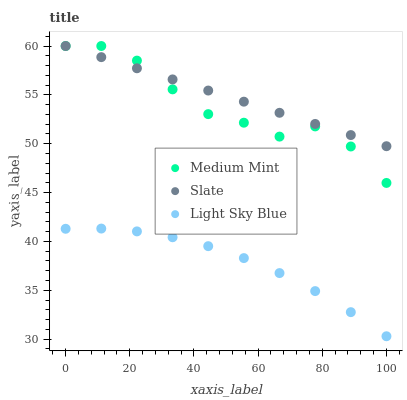Does Light Sky Blue have the minimum area under the curve?
Answer yes or no. Yes. Does Slate have the maximum area under the curve?
Answer yes or no. Yes. Does Slate have the minimum area under the curve?
Answer yes or no. No. Does Light Sky Blue have the maximum area under the curve?
Answer yes or no. No. Is Slate the smoothest?
Answer yes or no. Yes. Is Medium Mint the roughest?
Answer yes or no. Yes. Is Light Sky Blue the smoothest?
Answer yes or no. No. Is Light Sky Blue the roughest?
Answer yes or no. No. Does Light Sky Blue have the lowest value?
Answer yes or no. Yes. Does Slate have the lowest value?
Answer yes or no. No. Does Slate have the highest value?
Answer yes or no. Yes. Does Light Sky Blue have the highest value?
Answer yes or no. No. Is Light Sky Blue less than Medium Mint?
Answer yes or no. Yes. Is Medium Mint greater than Light Sky Blue?
Answer yes or no. Yes. Does Medium Mint intersect Slate?
Answer yes or no. Yes. Is Medium Mint less than Slate?
Answer yes or no. No. Is Medium Mint greater than Slate?
Answer yes or no. No. Does Light Sky Blue intersect Medium Mint?
Answer yes or no. No. 